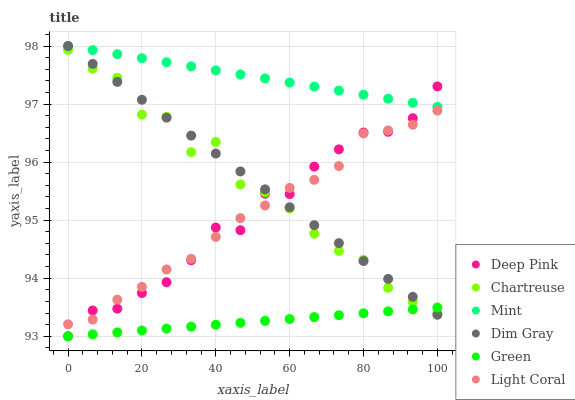Does Green have the minimum area under the curve?
Answer yes or no. Yes. Does Mint have the maximum area under the curve?
Answer yes or no. Yes. Does Light Coral have the minimum area under the curve?
Answer yes or no. No. Does Light Coral have the maximum area under the curve?
Answer yes or no. No. Is Green the smoothest?
Answer yes or no. Yes. Is Chartreuse the roughest?
Answer yes or no. Yes. Is Light Coral the smoothest?
Answer yes or no. No. Is Light Coral the roughest?
Answer yes or no. No. Does Deep Pink have the lowest value?
Answer yes or no. Yes. Does Light Coral have the lowest value?
Answer yes or no. No. Does Mint have the highest value?
Answer yes or no. Yes. Does Light Coral have the highest value?
Answer yes or no. No. Is Green less than Light Coral?
Answer yes or no. Yes. Is Mint greater than Green?
Answer yes or no. Yes. Does Deep Pink intersect Green?
Answer yes or no. Yes. Is Deep Pink less than Green?
Answer yes or no. No. Is Deep Pink greater than Green?
Answer yes or no. No. Does Green intersect Light Coral?
Answer yes or no. No. 